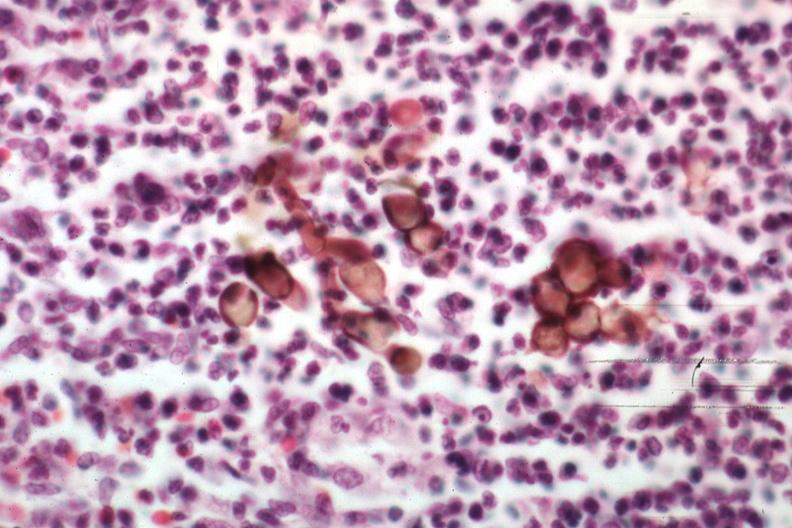what is present?
Answer the question using a single word or phrase. Chromoblastomycosis 